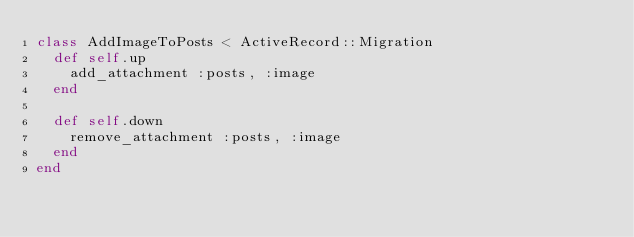Convert code to text. <code><loc_0><loc_0><loc_500><loc_500><_Ruby_>class AddImageToPosts < ActiveRecord::Migration
  def self.up
    add_attachment :posts, :image
  end

  def self.down
    remove_attachment :posts, :image
  end
end
</code> 